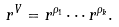<formula> <loc_0><loc_0><loc_500><loc_500>r ^ { V } = r ^ { \rho _ { 1 } } \cdots r ^ { \rho _ { k } } .</formula> 